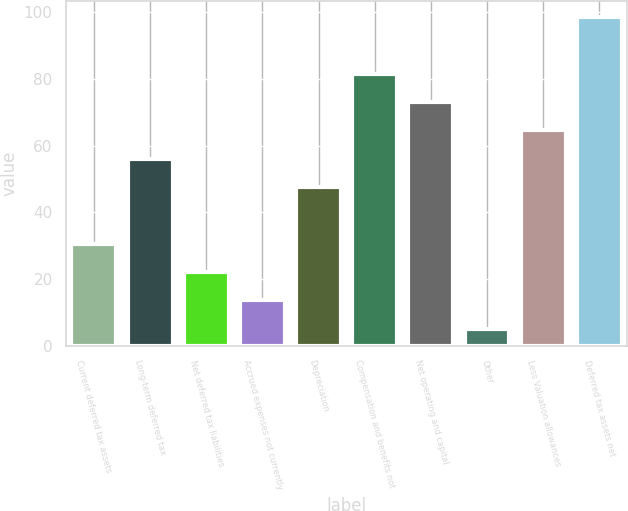Convert chart. <chart><loc_0><loc_0><loc_500><loc_500><bar_chart><fcel>Current deferred tax assets<fcel>Long-term deferred tax<fcel>Net deferred tax liabilities<fcel>Accrued expenses not currently<fcel>Depreciation<fcel>Compensation and benefits not<fcel>Net operating and capital<fcel>Other<fcel>Less Valuation allowances<fcel>Deferred tax assets net<nl><fcel>30.67<fcel>56.14<fcel>22.18<fcel>13.69<fcel>47.65<fcel>81.61<fcel>73.12<fcel>5.2<fcel>64.63<fcel>98.59<nl></chart> 